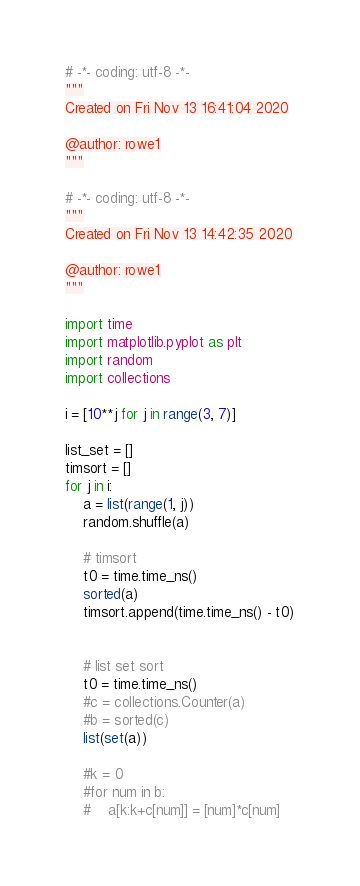<code> <loc_0><loc_0><loc_500><loc_500><_Python_># -*- coding: utf-8 -*-
"""
Created on Fri Nov 13 16:41:04 2020

@author: rowe1
"""

# -*- coding: utf-8 -*-
"""
Created on Fri Nov 13 14:42:35 2020

@author: rowe1
"""

import time
import matplotlib.pyplot as plt
import random
import collections

i = [10**j for j in range(3, 7)]

list_set = []
timsort = []
for j in i:
    a = list(range(1, j))
    random.shuffle(a)
    
    # timsort
    t0 = time.time_ns()
    sorted(a)
    timsort.append(time.time_ns() - t0)
    
    
    # list set sort
    t0 = time.time_ns()
    #c = collections.Counter(a)
    #b = sorted(c)
    list(set(a))
    
    #k = 0
    #for num in b:
    #    a[k:k+c[num]] = [num]*c[num]</code> 